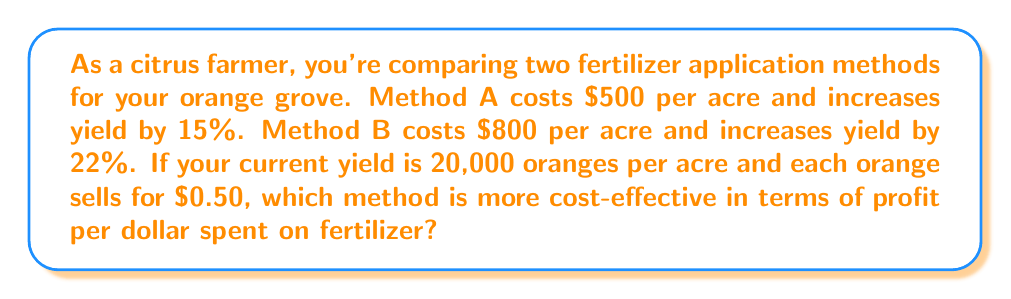Solve this math problem. Let's approach this step-by-step:

1) First, calculate the increase in oranges for each method:
   Method A: $20,000 \times 15\% = 3,000$ additional oranges
   Method B: $20,000 \times 22\% = 4,400$ additional oranges

2) Calculate the additional revenue for each method:
   Method A: $3,000 \times \$0.50 = \$1,500$
   Method B: $4,400 \times \$0.50 = \$2,200$

3) Calculate the net profit (additional revenue minus fertilizer cost):
   Method A: $\$1,500 - \$500 = \$1,000$
   Method B: $\$2,200 - \$800 = \$1,400$

4) Calculate the profit per dollar spent on fertilizer:
   Method A: $\frac{\$1,000}{\$500} = \$2$ profit per dollar spent
   Method B: $\frac{\$1,400}{\$800} = \$1.75$ profit per dollar spent

5) Compare the results:
   Method A yields $\$2$ profit per dollar spent on fertilizer
   Method B yields $\$1.75$ profit per dollar spent on fertilizer

Therefore, Method A is more cost-effective in terms of profit per dollar spent on fertilizer.
Answer: Method A 